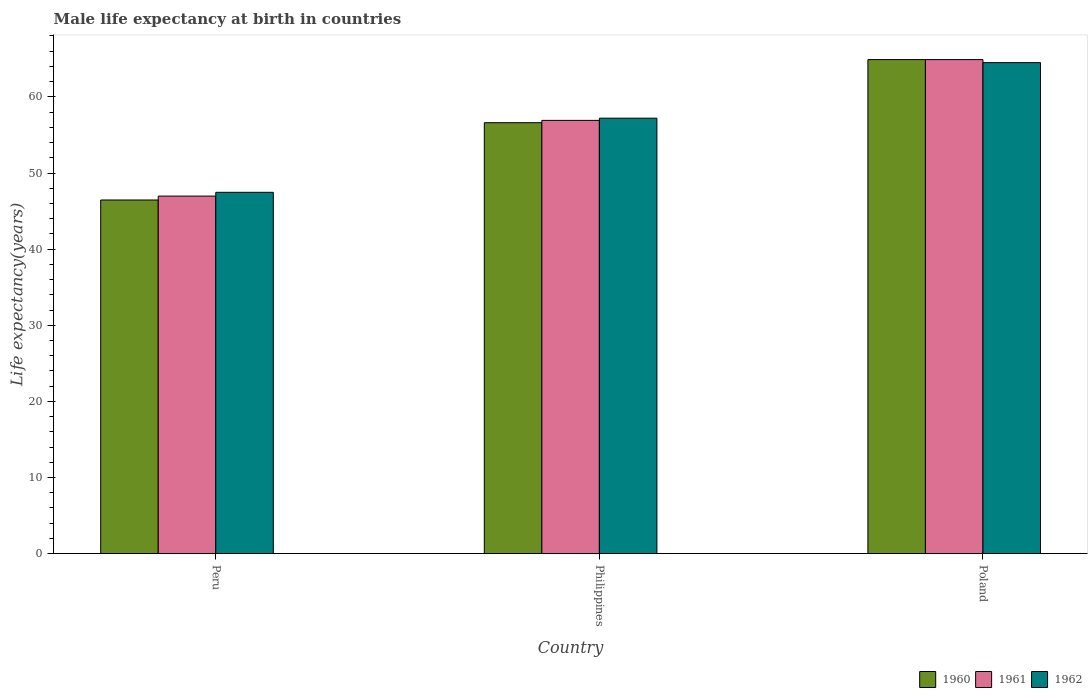How many different coloured bars are there?
Keep it short and to the point. 3. Are the number of bars per tick equal to the number of legend labels?
Provide a short and direct response. Yes. Are the number of bars on each tick of the X-axis equal?
Your response must be concise. Yes. How many bars are there on the 2nd tick from the right?
Provide a succinct answer. 3. In how many cases, is the number of bars for a given country not equal to the number of legend labels?
Provide a succinct answer. 0. What is the male life expectancy at birth in 1960 in Philippines?
Keep it short and to the point. 56.61. Across all countries, what is the maximum male life expectancy at birth in 1962?
Offer a very short reply. 64.5. Across all countries, what is the minimum male life expectancy at birth in 1962?
Keep it short and to the point. 47.46. What is the total male life expectancy at birth in 1961 in the graph?
Offer a terse response. 168.78. What is the difference between the male life expectancy at birth in 1961 in Peru and that in Poland?
Make the answer very short. -17.93. What is the difference between the male life expectancy at birth in 1961 in Philippines and the male life expectancy at birth in 1962 in Poland?
Provide a succinct answer. -7.59. What is the average male life expectancy at birth in 1962 per country?
Give a very brief answer. 56.39. What is the difference between the male life expectancy at birth of/in 1961 and male life expectancy at birth of/in 1962 in Poland?
Your answer should be very brief. 0.4. In how many countries, is the male life expectancy at birth in 1962 greater than 24 years?
Offer a very short reply. 3. What is the ratio of the male life expectancy at birth in 1960 in Philippines to that in Poland?
Make the answer very short. 0.87. What is the difference between the highest and the second highest male life expectancy at birth in 1961?
Make the answer very short. 7.99. What is the difference between the highest and the lowest male life expectancy at birth in 1961?
Offer a terse response. 17.93. Is the sum of the male life expectancy at birth in 1961 in Peru and Poland greater than the maximum male life expectancy at birth in 1960 across all countries?
Your response must be concise. Yes. What does the 2nd bar from the right in Philippines represents?
Your response must be concise. 1961. Are all the bars in the graph horizontal?
Your response must be concise. No. How many countries are there in the graph?
Your response must be concise. 3. What is the difference between two consecutive major ticks on the Y-axis?
Offer a terse response. 10. How many legend labels are there?
Your response must be concise. 3. How are the legend labels stacked?
Your response must be concise. Horizontal. What is the title of the graph?
Offer a very short reply. Male life expectancy at birth in countries. What is the label or title of the X-axis?
Provide a short and direct response. Country. What is the label or title of the Y-axis?
Give a very brief answer. Life expectancy(years). What is the Life expectancy(years) in 1960 in Peru?
Give a very brief answer. 46.45. What is the Life expectancy(years) of 1961 in Peru?
Provide a succinct answer. 46.97. What is the Life expectancy(years) in 1962 in Peru?
Offer a terse response. 47.46. What is the Life expectancy(years) in 1960 in Philippines?
Give a very brief answer. 56.61. What is the Life expectancy(years) of 1961 in Philippines?
Offer a very short reply. 56.91. What is the Life expectancy(years) of 1962 in Philippines?
Provide a succinct answer. 57.2. What is the Life expectancy(years) of 1960 in Poland?
Offer a very short reply. 64.9. What is the Life expectancy(years) of 1961 in Poland?
Offer a terse response. 64.9. What is the Life expectancy(years) in 1962 in Poland?
Provide a succinct answer. 64.5. Across all countries, what is the maximum Life expectancy(years) in 1960?
Make the answer very short. 64.9. Across all countries, what is the maximum Life expectancy(years) in 1961?
Offer a terse response. 64.9. Across all countries, what is the maximum Life expectancy(years) of 1962?
Give a very brief answer. 64.5. Across all countries, what is the minimum Life expectancy(years) in 1960?
Your response must be concise. 46.45. Across all countries, what is the minimum Life expectancy(years) in 1961?
Offer a very short reply. 46.97. Across all countries, what is the minimum Life expectancy(years) of 1962?
Provide a succinct answer. 47.46. What is the total Life expectancy(years) of 1960 in the graph?
Offer a terse response. 167.96. What is the total Life expectancy(years) in 1961 in the graph?
Offer a very short reply. 168.78. What is the total Life expectancy(years) in 1962 in the graph?
Offer a very short reply. 169.17. What is the difference between the Life expectancy(years) in 1960 in Peru and that in Philippines?
Your answer should be very brief. -10.15. What is the difference between the Life expectancy(years) of 1961 in Peru and that in Philippines?
Your answer should be very brief. -9.94. What is the difference between the Life expectancy(years) of 1962 in Peru and that in Philippines?
Provide a short and direct response. -9.74. What is the difference between the Life expectancy(years) in 1960 in Peru and that in Poland?
Keep it short and to the point. -18.45. What is the difference between the Life expectancy(years) in 1961 in Peru and that in Poland?
Offer a terse response. -17.93. What is the difference between the Life expectancy(years) in 1962 in Peru and that in Poland?
Keep it short and to the point. -17.04. What is the difference between the Life expectancy(years) in 1960 in Philippines and that in Poland?
Your answer should be very brief. -8.29. What is the difference between the Life expectancy(years) of 1961 in Philippines and that in Poland?
Offer a terse response. -7.99. What is the difference between the Life expectancy(years) of 1962 in Philippines and that in Poland?
Offer a terse response. -7.3. What is the difference between the Life expectancy(years) in 1960 in Peru and the Life expectancy(years) in 1961 in Philippines?
Your answer should be very brief. -10.46. What is the difference between the Life expectancy(years) of 1960 in Peru and the Life expectancy(years) of 1962 in Philippines?
Keep it short and to the point. -10.75. What is the difference between the Life expectancy(years) of 1961 in Peru and the Life expectancy(years) of 1962 in Philippines?
Provide a short and direct response. -10.23. What is the difference between the Life expectancy(years) in 1960 in Peru and the Life expectancy(years) in 1961 in Poland?
Give a very brief answer. -18.45. What is the difference between the Life expectancy(years) in 1960 in Peru and the Life expectancy(years) in 1962 in Poland?
Make the answer very short. -18.05. What is the difference between the Life expectancy(years) of 1961 in Peru and the Life expectancy(years) of 1962 in Poland?
Provide a short and direct response. -17.53. What is the difference between the Life expectancy(years) in 1960 in Philippines and the Life expectancy(years) in 1961 in Poland?
Give a very brief answer. -8.29. What is the difference between the Life expectancy(years) of 1960 in Philippines and the Life expectancy(years) of 1962 in Poland?
Provide a succinct answer. -7.89. What is the difference between the Life expectancy(years) in 1961 in Philippines and the Life expectancy(years) in 1962 in Poland?
Offer a very short reply. -7.59. What is the average Life expectancy(years) in 1960 per country?
Your answer should be compact. 55.99. What is the average Life expectancy(years) in 1961 per country?
Provide a short and direct response. 56.26. What is the average Life expectancy(years) of 1962 per country?
Offer a very short reply. 56.39. What is the difference between the Life expectancy(years) in 1960 and Life expectancy(years) in 1961 in Peru?
Your answer should be very brief. -0.52. What is the difference between the Life expectancy(years) of 1960 and Life expectancy(years) of 1962 in Peru?
Make the answer very short. -1.01. What is the difference between the Life expectancy(years) of 1961 and Life expectancy(years) of 1962 in Peru?
Offer a very short reply. -0.49. What is the difference between the Life expectancy(years) in 1960 and Life expectancy(years) in 1961 in Philippines?
Give a very brief answer. -0.3. What is the difference between the Life expectancy(years) in 1960 and Life expectancy(years) in 1962 in Philippines?
Ensure brevity in your answer.  -0.59. What is the difference between the Life expectancy(years) in 1961 and Life expectancy(years) in 1962 in Philippines?
Ensure brevity in your answer.  -0.29. What is the difference between the Life expectancy(years) in 1960 and Life expectancy(years) in 1961 in Poland?
Your answer should be compact. 0. What is the difference between the Life expectancy(years) in 1960 and Life expectancy(years) in 1962 in Poland?
Provide a short and direct response. 0.4. What is the difference between the Life expectancy(years) of 1961 and Life expectancy(years) of 1962 in Poland?
Make the answer very short. 0.4. What is the ratio of the Life expectancy(years) of 1960 in Peru to that in Philippines?
Your answer should be compact. 0.82. What is the ratio of the Life expectancy(years) in 1961 in Peru to that in Philippines?
Give a very brief answer. 0.83. What is the ratio of the Life expectancy(years) in 1962 in Peru to that in Philippines?
Your answer should be very brief. 0.83. What is the ratio of the Life expectancy(years) in 1960 in Peru to that in Poland?
Your response must be concise. 0.72. What is the ratio of the Life expectancy(years) in 1961 in Peru to that in Poland?
Your answer should be compact. 0.72. What is the ratio of the Life expectancy(years) of 1962 in Peru to that in Poland?
Ensure brevity in your answer.  0.74. What is the ratio of the Life expectancy(years) of 1960 in Philippines to that in Poland?
Offer a terse response. 0.87. What is the ratio of the Life expectancy(years) of 1961 in Philippines to that in Poland?
Ensure brevity in your answer.  0.88. What is the ratio of the Life expectancy(years) in 1962 in Philippines to that in Poland?
Keep it short and to the point. 0.89. What is the difference between the highest and the second highest Life expectancy(years) in 1960?
Your response must be concise. 8.29. What is the difference between the highest and the second highest Life expectancy(years) of 1961?
Make the answer very short. 7.99. What is the difference between the highest and the second highest Life expectancy(years) in 1962?
Keep it short and to the point. 7.3. What is the difference between the highest and the lowest Life expectancy(years) in 1960?
Offer a terse response. 18.45. What is the difference between the highest and the lowest Life expectancy(years) in 1961?
Ensure brevity in your answer.  17.93. What is the difference between the highest and the lowest Life expectancy(years) of 1962?
Provide a short and direct response. 17.04. 